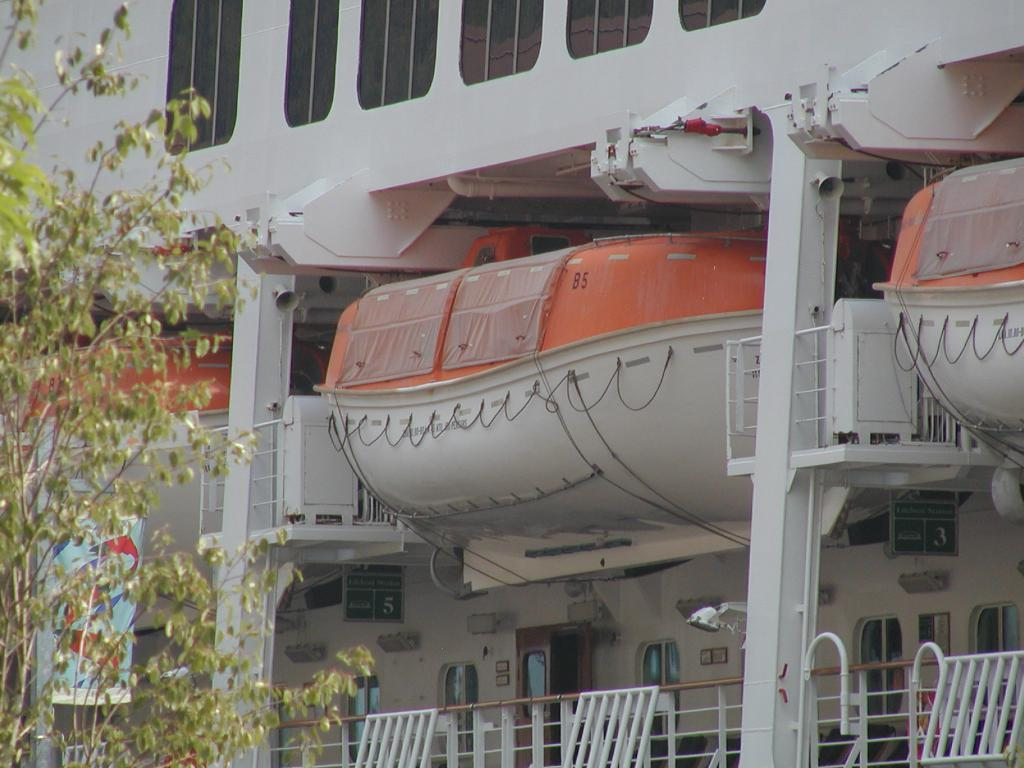What is the main subject of the image? The main subject of the image is a ship. What safety features are visible on the ship? There are lifeboats in the image. What can be seen at the bottom of the image? There is a railing at the bottom of the image. What type of vegetation is on the left side of the image? There are trees on the left side of the image. What color is the pail that is being used to temper the flesh in the image? There is no pail, tempering, or flesh present in the image. 